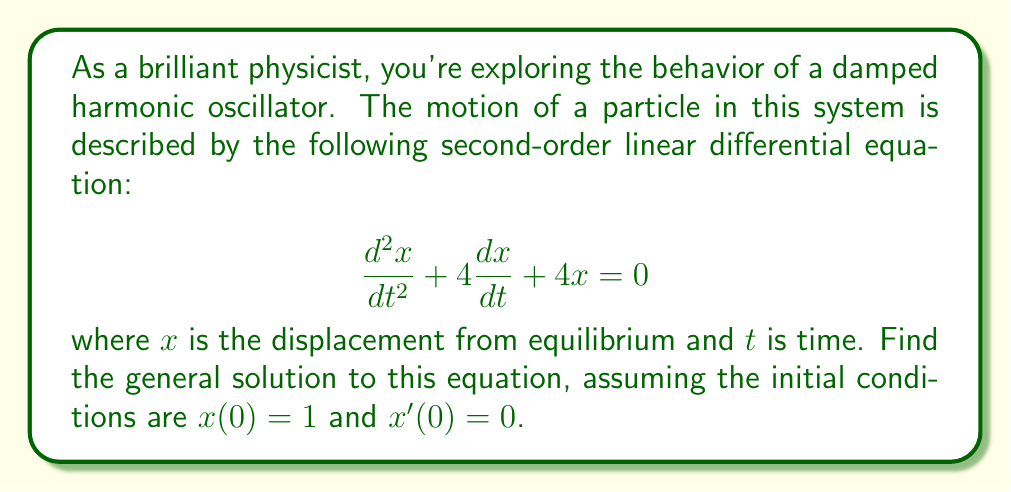What is the answer to this math problem? To solve this second-order linear differential equation with constant coefficients, we'll follow these steps:

1) First, we need to find the characteristic equation. For a differential equation in the form:

   $$\frac{d^2x}{dt^2} + a\frac{dx}{dt} + bx = 0$$

   The characteristic equation is:

   $$r^2 + ar + b = 0$$

2) In our case, $a = 4$ and $b = 4$, so our characteristic equation is:

   $$r^2 + 4r + 4 = 0$$

3) We can solve this using the quadratic formula: $r = \frac{-b \pm \sqrt{b^2 - 4ac}}{2a}$

   $$r = \frac{-4 \pm \sqrt{16 - 16}}{2} = \frac{-4 \pm 0}{2} = -2$$

4) We have a repeated root, $r = -2$. For a repeated root, the general solution takes the form:

   $$x(t) = (C_1 + C_2t)e^{rt}$$

   where $C_1$ and $C_2$ are constants to be determined by initial conditions.

5) Substituting our value for $r$:

   $$x(t) = (C_1 + C_2t)e^{-2t}$$

6) To find $C_1$ and $C_2$, we use the initial conditions:

   For $x(0) = 1$:
   $$1 = C_1 + 0 \cdot C_2 \implies C_1 = 1$$

   For $x'(0) = 0$, we first need to find $x'(t)$:
   $$x'(t) = C_2e^{-2t} + (C_1 + C_2t)(-2)e^{-2t} = (C_2 - 2C_1 - 2C_2t)e^{-2t}$$

   Then:
   $$0 = C_2 - 2C_1 \implies C_2 = 2C_1 = 2$$

7) Therefore, our final solution is:

   $$x(t) = (1 + 2t)e^{-2t}$$
Answer: $x(t) = (1 + 2t)e^{-2t}$ 